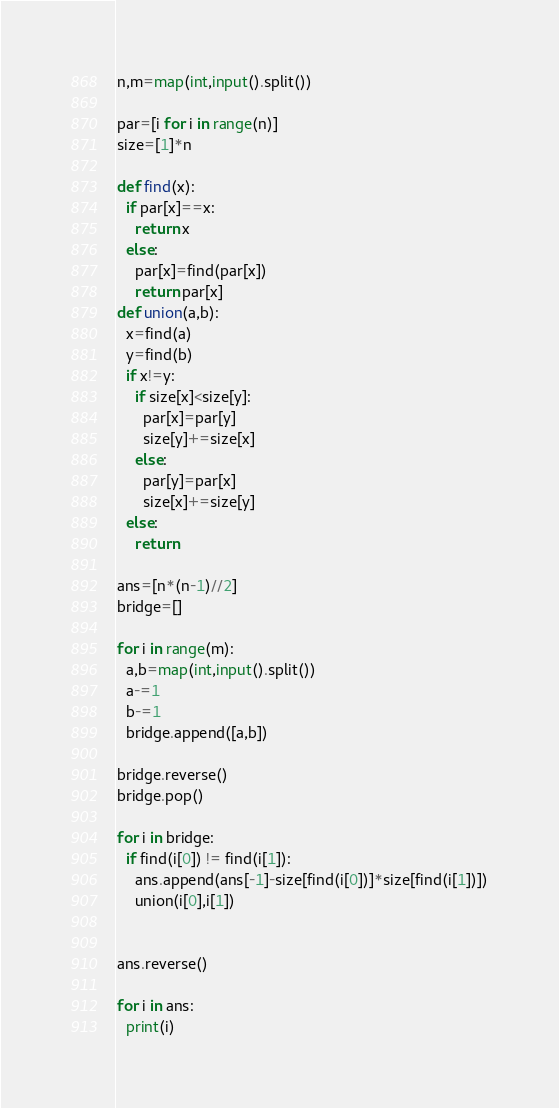<code> <loc_0><loc_0><loc_500><loc_500><_Python_>n,m=map(int,input().split())

par=[i for i in range(n)]
size=[1]*n

def find(x):
  if par[x]==x:
    return x
  else:
    par[x]=find(par[x])
    return par[x]
def union(a,b):
  x=find(a)
  y=find(b)
  if x!=y:
    if size[x]<size[y]:
      par[x]=par[y]
      size[y]+=size[x]
    else: 
      par[y]=par[x]
      size[x]+=size[y]
  else:
    return

ans=[n*(n-1)//2]
bridge=[]

for i in range(m):
  a,b=map(int,input().split())
  a-=1
  b-=1
  bridge.append([a,b])

bridge.reverse()
bridge.pop()

for i in bridge:
  if find(i[0]) != find(i[1]):
    ans.append(ans[-1]-size[find(i[0])]*size[find(i[1])])
    union(i[0],i[1])


ans.reverse()

for i in ans:
  print(i)</code> 